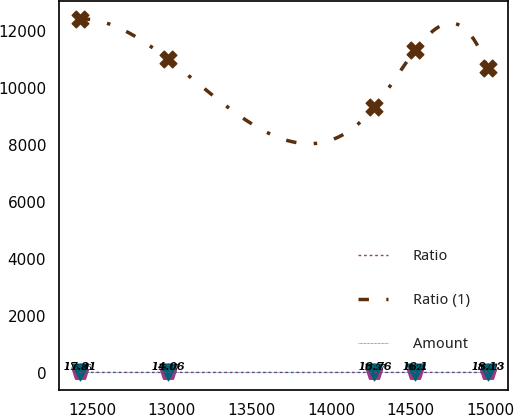<chart> <loc_0><loc_0><loc_500><loc_500><line_chart><ecel><fcel>Ratio<fcel>Ratio (1)<fcel>Amount<nl><fcel>12422<fcel>16.86<fcel>12413<fcel>17.31<nl><fcel>12974.8<fcel>15.17<fcel>11010<fcel>14.06<nl><fcel>14272.8<fcel>17.27<fcel>9321.1<fcel>16.76<nl><fcel>14528.9<fcel>19.24<fcel>11319.2<fcel>16.1<nl><fcel>14982.9<fcel>16.01<fcel>10700.9<fcel>18.13<nl></chart> 